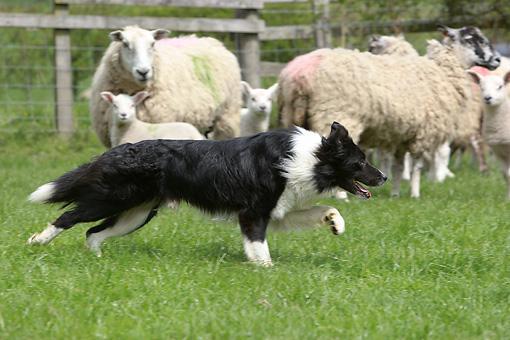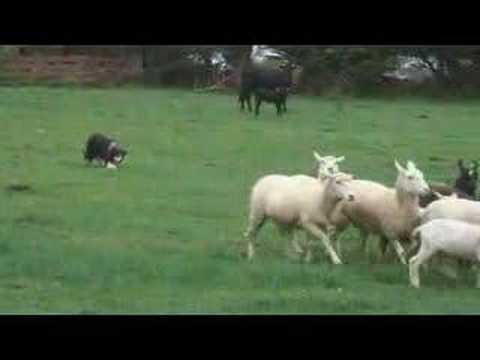The first image is the image on the left, the second image is the image on the right. For the images displayed, is the sentence "An image shows the dog in profile, centered in front of a group of animals." factually correct? Answer yes or no. Yes. 